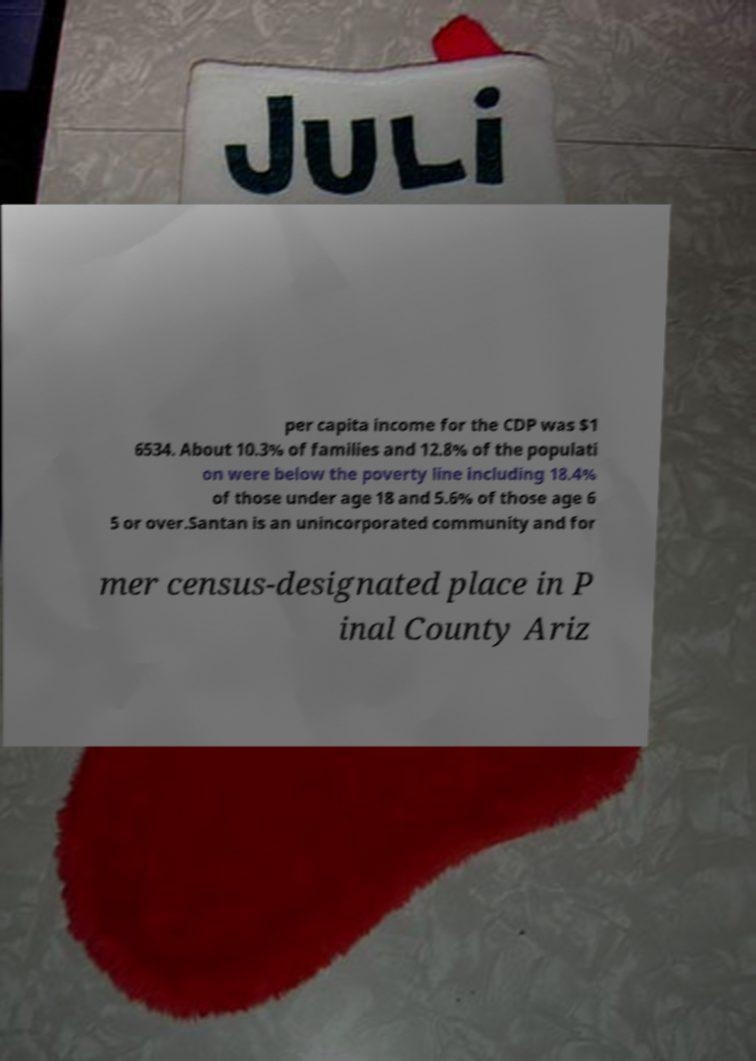Please identify and transcribe the text found in this image. per capita income for the CDP was $1 6534. About 10.3% of families and 12.8% of the populati on were below the poverty line including 18.4% of those under age 18 and 5.6% of those age 6 5 or over.Santan is an unincorporated community and for mer census-designated place in P inal County Ariz 